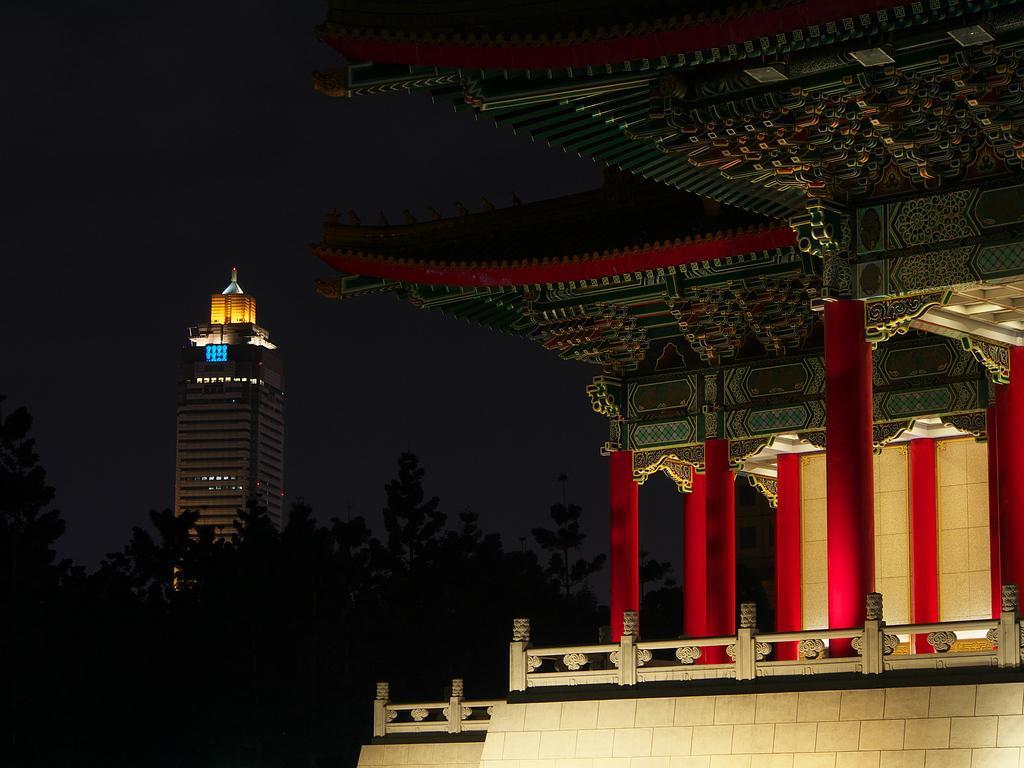In one or two sentences, can you explain what this image depicts? This is an image clicked in the dark. On the right side there is a building along with the pillars. In the background there are many trees and also I can see a building. At the top, I can see the sky. 